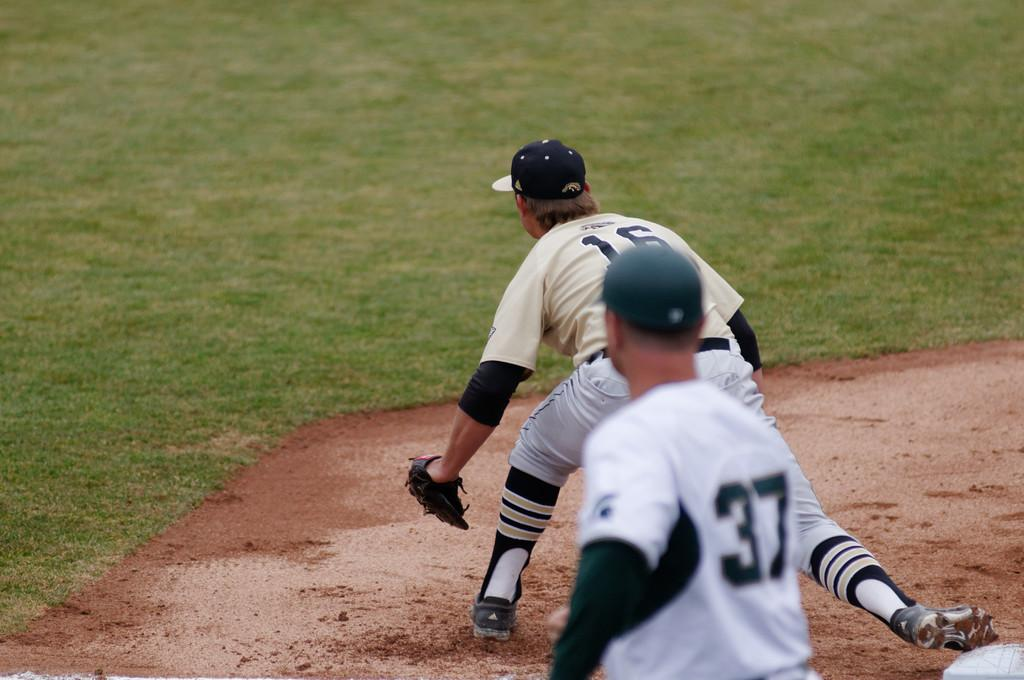<image>
Write a terse but informative summary of the picture. a person that has the number 16 on the back of their jersey 